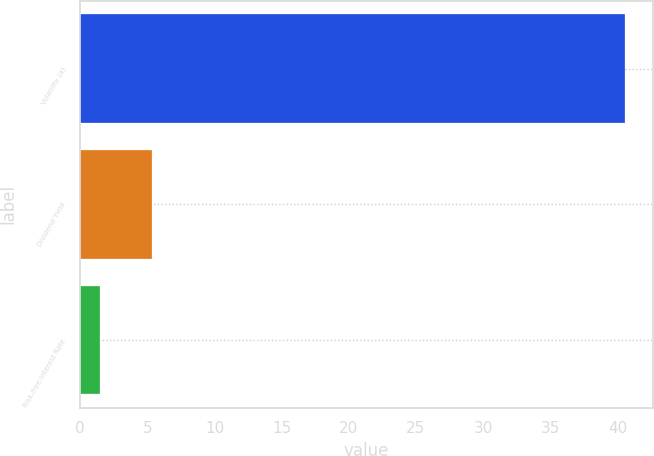Convert chart. <chart><loc_0><loc_0><loc_500><loc_500><bar_chart><fcel>Volatility (a)<fcel>Dividend Yield<fcel>Risk-free Interest Rate<nl><fcel>40.6<fcel>5.38<fcel>1.47<nl></chart> 